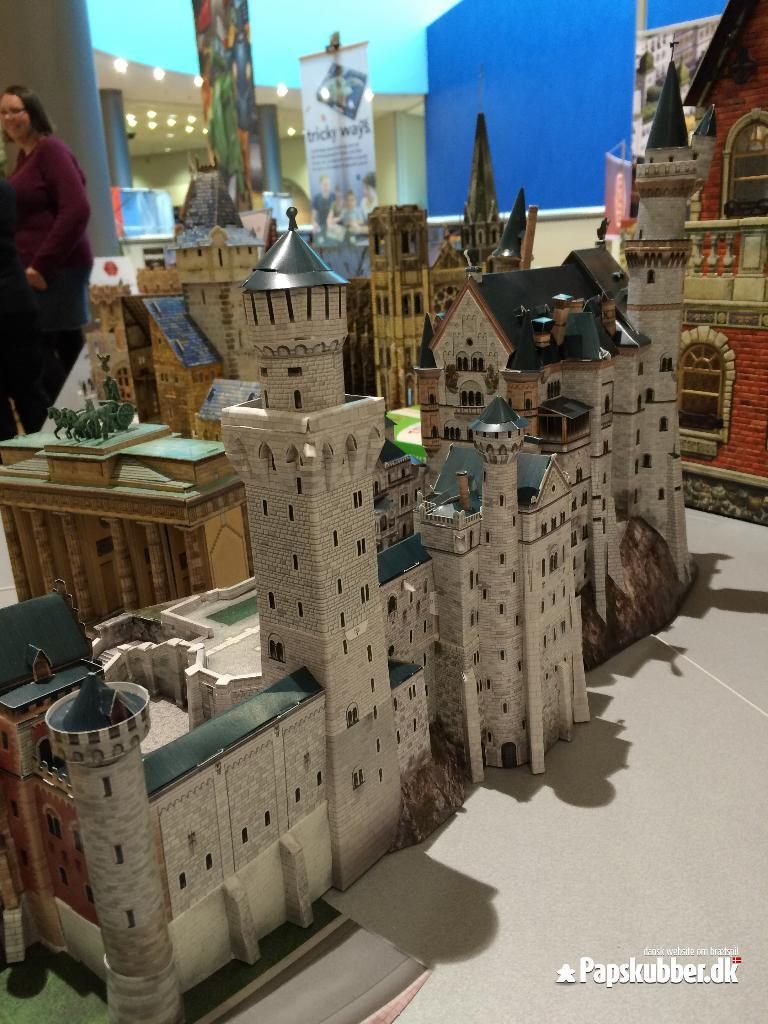What type of structures are depicted in the image? There are artificial castles in the image. Can you describe the background of the image? In the background of the image, there is a person standing, a banner, a wall, and lights. What is the purpose of the banner in the image? The purpose of the banner cannot be determined from the image alone. Is there any indication of a watermark on the image? Yes, there is a watermark on the image. What type of disease is being treated by the person in the image? There is no person being treated for a disease in the image; the person is simply standing in the background. Can you hear the whistle in the image? There is no whistle present in the image, so it cannot be heard. 